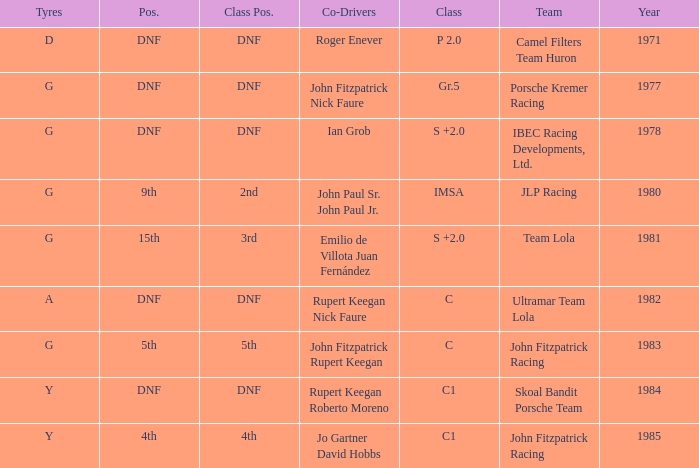Who was the co-driver that had a class position of 2nd? John Paul Sr. John Paul Jr. 